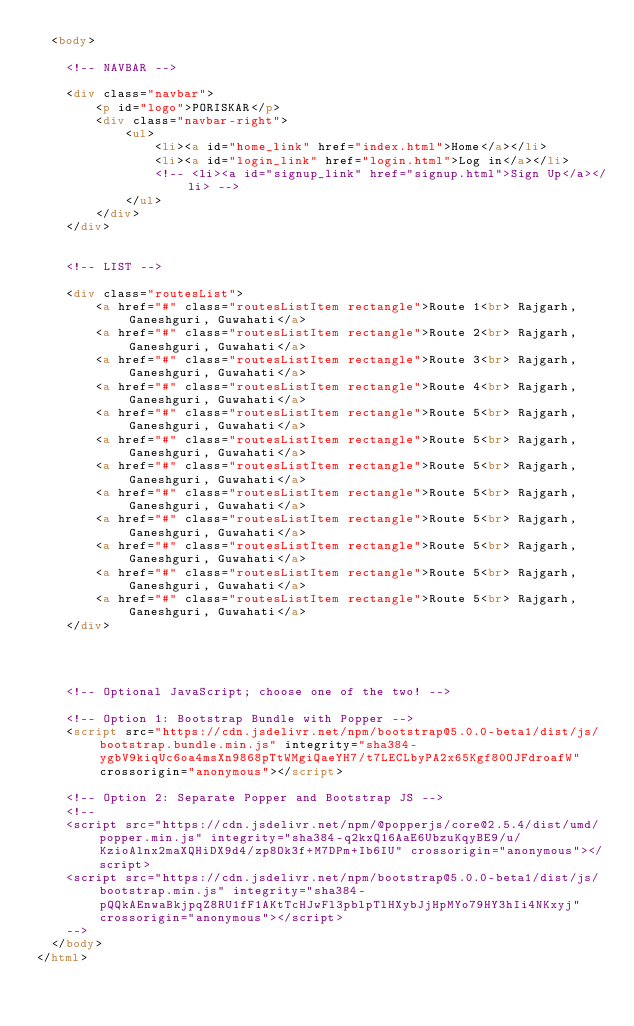Convert code to text. <code><loc_0><loc_0><loc_500><loc_500><_HTML_>  <body>
    
    <!-- NAVBAR -->

    <div class="navbar">
        <p id="logo">PORISKAR</p>
        <div class="navbar-right">
            <ul>
                <li><a id="home_link" href="index.html">Home</a></li>
                <li><a id="login_link" href="login.html">Log in</a></li>
                <!-- <li><a id="signup_link" href="signup.html">Sign Up</a></li> -->
            </ul>
        </div>
    </div>


    <!-- LIST -->

    <div class="routesList">
        <a href="#" class="routesListItem rectangle">Route 1<br> Rajgarh, Ganeshguri, Guwahati</a>
        <a href="#" class="routesListItem rectangle">Route 2<br> Rajgarh, Ganeshguri, Guwahati</a>
        <a href="#" class="routesListItem rectangle">Route 3<br> Rajgarh, Ganeshguri, Guwahati</a>
        <a href="#" class="routesListItem rectangle">Route 4<br> Rajgarh, Ganeshguri, Guwahati</a>
        <a href="#" class="routesListItem rectangle">Route 5<br> Rajgarh, Ganeshguri, Guwahati</a>
        <a href="#" class="routesListItem rectangle">Route 5<br> Rajgarh, Ganeshguri, Guwahati</a>
        <a href="#" class="routesListItem rectangle">Route 5<br> Rajgarh, Ganeshguri, Guwahati</a>
        <a href="#" class="routesListItem rectangle">Route 5<br> Rajgarh, Ganeshguri, Guwahati</a>
        <a href="#" class="routesListItem rectangle">Route 5<br> Rajgarh, Ganeshguri, Guwahati</a>
        <a href="#" class="routesListItem rectangle">Route 5<br> Rajgarh, Ganeshguri, Guwahati</a>
        <a href="#" class="routesListItem rectangle">Route 5<br> Rajgarh, Ganeshguri, Guwahati</a>
        <a href="#" class="routesListItem rectangle">Route 5<br> Rajgarh, Ganeshguri, Guwahati</a>
    </div>


    

    <!-- Optional JavaScript; choose one of the two! -->

    <!-- Option 1: Bootstrap Bundle with Popper -->
    <script src="https://cdn.jsdelivr.net/npm/bootstrap@5.0.0-beta1/dist/js/bootstrap.bundle.min.js" integrity="sha384-ygbV9kiqUc6oa4msXn9868pTtWMgiQaeYH7/t7LECLbyPA2x65Kgf80OJFdroafW" crossorigin="anonymous"></script>

    <!-- Option 2: Separate Popper and Bootstrap JS -->
    <!--
    <script src="https://cdn.jsdelivr.net/npm/@popperjs/core@2.5.4/dist/umd/popper.min.js" integrity="sha384-q2kxQ16AaE6UbzuKqyBE9/u/KzioAlnx2maXQHiDX9d4/zp8Ok3f+M7DPm+Ib6IU" crossorigin="anonymous"></script>
    <script src="https://cdn.jsdelivr.net/npm/bootstrap@5.0.0-beta1/dist/js/bootstrap.min.js" integrity="sha384-pQQkAEnwaBkjpqZ8RU1fF1AKtTcHJwFl3pblpTlHXybJjHpMYo79HY3hIi4NKxyj" crossorigin="anonymous"></script>
    -->
  </body>
</html></code> 